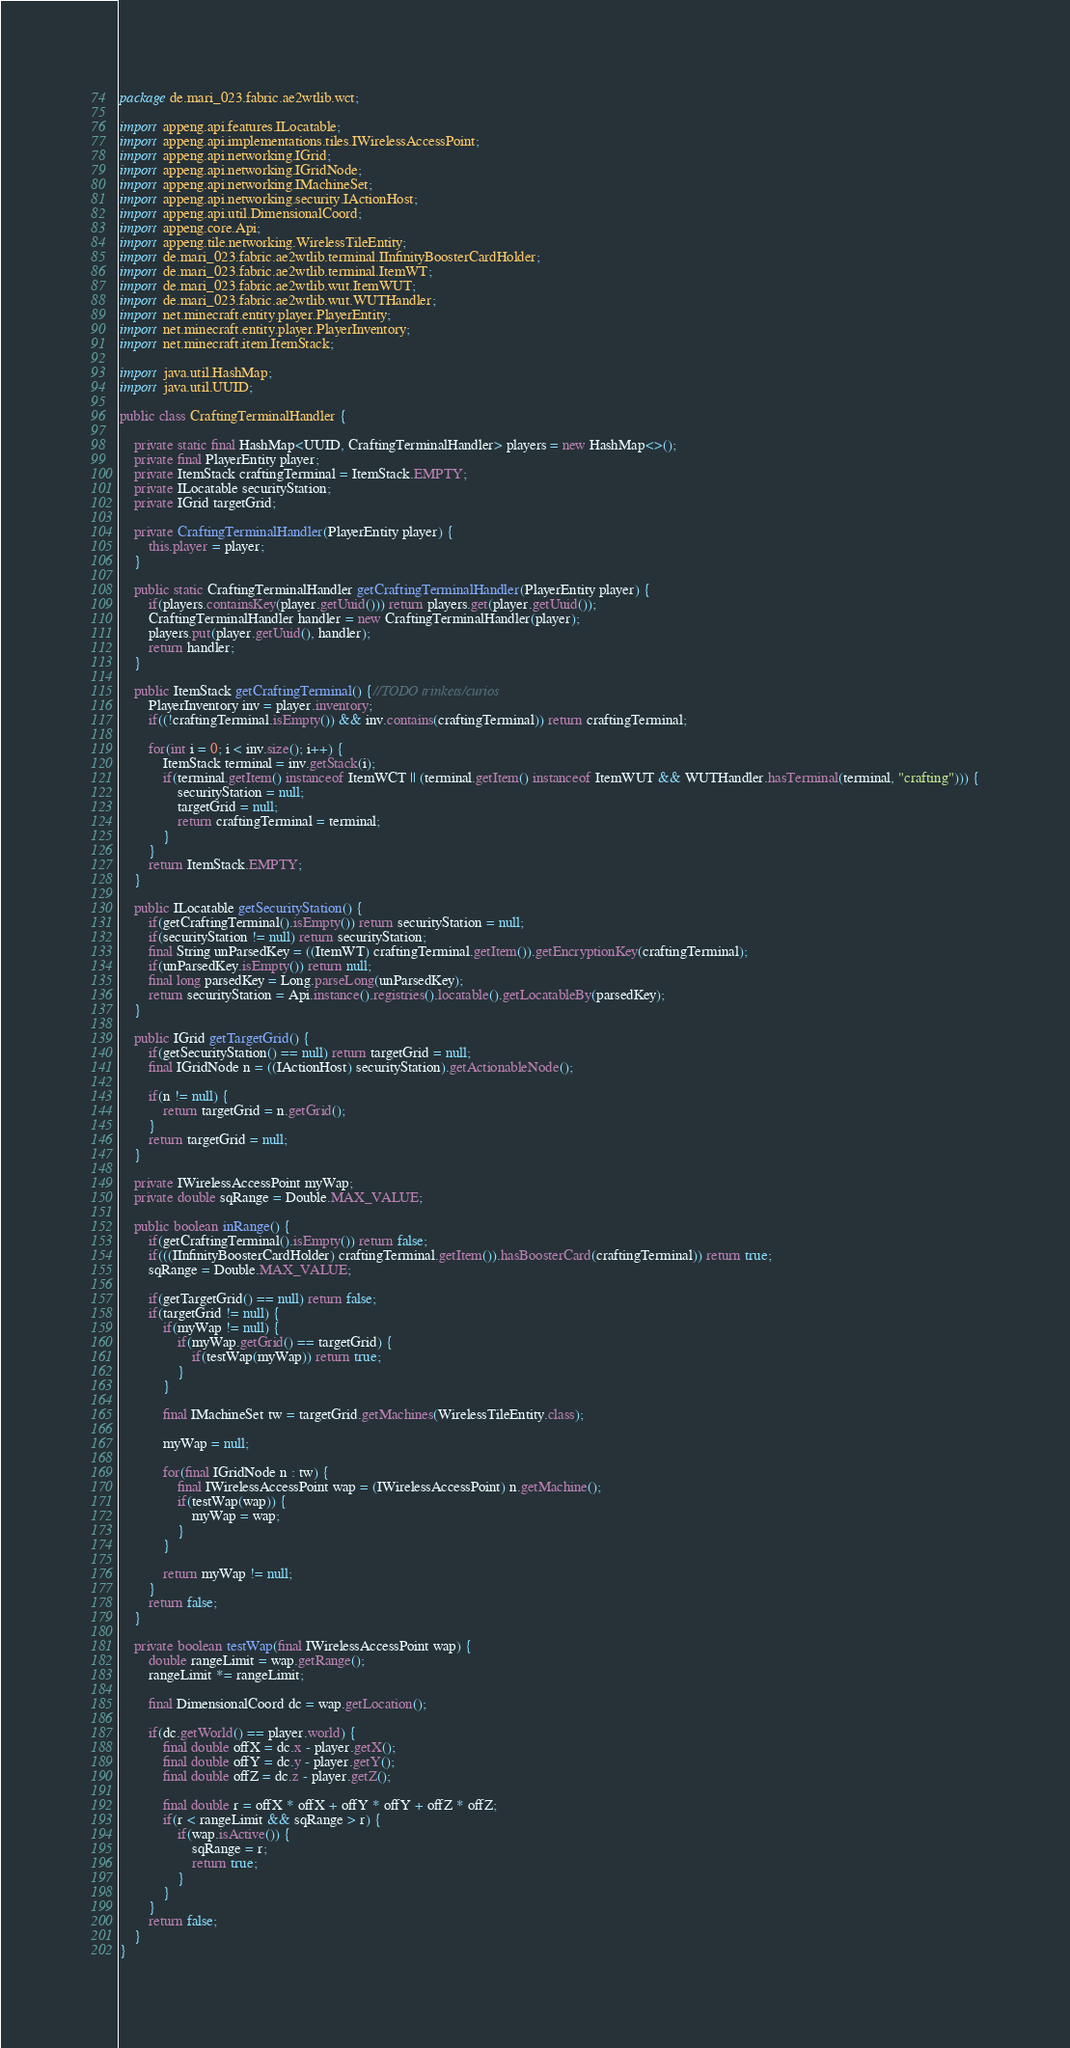<code> <loc_0><loc_0><loc_500><loc_500><_Java_>package de.mari_023.fabric.ae2wtlib.wct;

import appeng.api.features.ILocatable;
import appeng.api.implementations.tiles.IWirelessAccessPoint;
import appeng.api.networking.IGrid;
import appeng.api.networking.IGridNode;
import appeng.api.networking.IMachineSet;
import appeng.api.networking.security.IActionHost;
import appeng.api.util.DimensionalCoord;
import appeng.core.Api;
import appeng.tile.networking.WirelessTileEntity;
import de.mari_023.fabric.ae2wtlib.terminal.IInfinityBoosterCardHolder;
import de.mari_023.fabric.ae2wtlib.terminal.ItemWT;
import de.mari_023.fabric.ae2wtlib.wut.ItemWUT;
import de.mari_023.fabric.ae2wtlib.wut.WUTHandler;
import net.minecraft.entity.player.PlayerEntity;
import net.minecraft.entity.player.PlayerInventory;
import net.minecraft.item.ItemStack;

import java.util.HashMap;
import java.util.UUID;

public class CraftingTerminalHandler {

    private static final HashMap<UUID, CraftingTerminalHandler> players = new HashMap<>();
    private final PlayerEntity player;
    private ItemStack craftingTerminal = ItemStack.EMPTY;
    private ILocatable securityStation;
    private IGrid targetGrid;

    private CraftingTerminalHandler(PlayerEntity player) {
        this.player = player;
    }

    public static CraftingTerminalHandler getCraftingTerminalHandler(PlayerEntity player) {
        if(players.containsKey(player.getUuid())) return players.get(player.getUuid());
        CraftingTerminalHandler handler = new CraftingTerminalHandler(player);
        players.put(player.getUuid(), handler);
        return handler;
    }

    public ItemStack getCraftingTerminal() {//TODO trinkets/curios
        PlayerInventory inv = player.inventory;
        if((!craftingTerminal.isEmpty()) && inv.contains(craftingTerminal)) return craftingTerminal;

        for(int i = 0; i < inv.size(); i++) {
            ItemStack terminal = inv.getStack(i);
            if(terminal.getItem() instanceof ItemWCT || (terminal.getItem() instanceof ItemWUT && WUTHandler.hasTerminal(terminal, "crafting"))) {
                securityStation = null;
                targetGrid = null;
                return craftingTerminal = terminal;
            }
        }
        return ItemStack.EMPTY;
    }

    public ILocatable getSecurityStation() {
        if(getCraftingTerminal().isEmpty()) return securityStation = null;
        if(securityStation != null) return securityStation;
        final String unParsedKey = ((ItemWT) craftingTerminal.getItem()).getEncryptionKey(craftingTerminal);
        if(unParsedKey.isEmpty()) return null;
        final long parsedKey = Long.parseLong(unParsedKey);
        return securityStation = Api.instance().registries().locatable().getLocatableBy(parsedKey);
    }

    public IGrid getTargetGrid() {
        if(getSecurityStation() == null) return targetGrid = null;
        final IGridNode n = ((IActionHost) securityStation).getActionableNode();

        if(n != null) {
            return targetGrid = n.getGrid();
        }
        return targetGrid = null;
    }

    private IWirelessAccessPoint myWap;
    private double sqRange = Double.MAX_VALUE;

    public boolean inRange() {
        if(getCraftingTerminal().isEmpty()) return false;
        if(((IInfinityBoosterCardHolder) craftingTerminal.getItem()).hasBoosterCard(craftingTerminal)) return true;
        sqRange = Double.MAX_VALUE;

        if(getTargetGrid() == null) return false;
        if(targetGrid != null) {
            if(myWap != null) {
                if(myWap.getGrid() == targetGrid) {
                    if(testWap(myWap)) return true;
                }
            }

            final IMachineSet tw = targetGrid.getMachines(WirelessTileEntity.class);

            myWap = null;

            for(final IGridNode n : tw) {
                final IWirelessAccessPoint wap = (IWirelessAccessPoint) n.getMachine();
                if(testWap(wap)) {
                    myWap = wap;
                }
            }

            return myWap != null;
        }
        return false;
    }

    private boolean testWap(final IWirelessAccessPoint wap) {
        double rangeLimit = wap.getRange();
        rangeLimit *= rangeLimit;

        final DimensionalCoord dc = wap.getLocation();

        if(dc.getWorld() == player.world) {
            final double offX = dc.x - player.getX();
            final double offY = dc.y - player.getY();
            final double offZ = dc.z - player.getZ();

            final double r = offX * offX + offY * offY + offZ * offZ;
            if(r < rangeLimit && sqRange > r) {
                if(wap.isActive()) {
                    sqRange = r;
                    return true;
                }
            }
        }
        return false;
    }
}</code> 